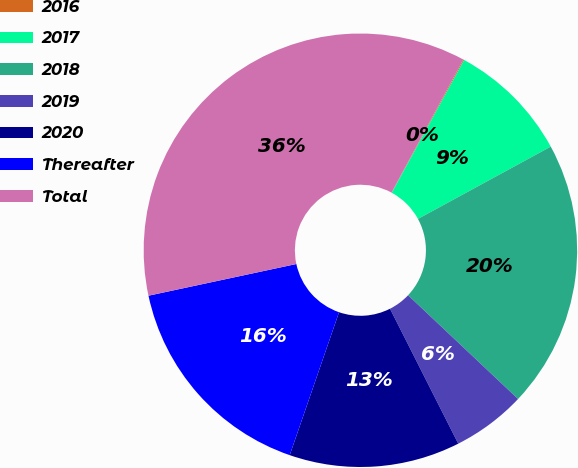Convert chart to OTSL. <chart><loc_0><loc_0><loc_500><loc_500><pie_chart><fcel>2016<fcel>2017<fcel>2018<fcel>2019<fcel>2020<fcel>Thereafter<fcel>Total<nl><fcel>0.07%<fcel>9.12%<fcel>19.97%<fcel>5.51%<fcel>12.74%<fcel>16.35%<fcel>36.23%<nl></chart> 